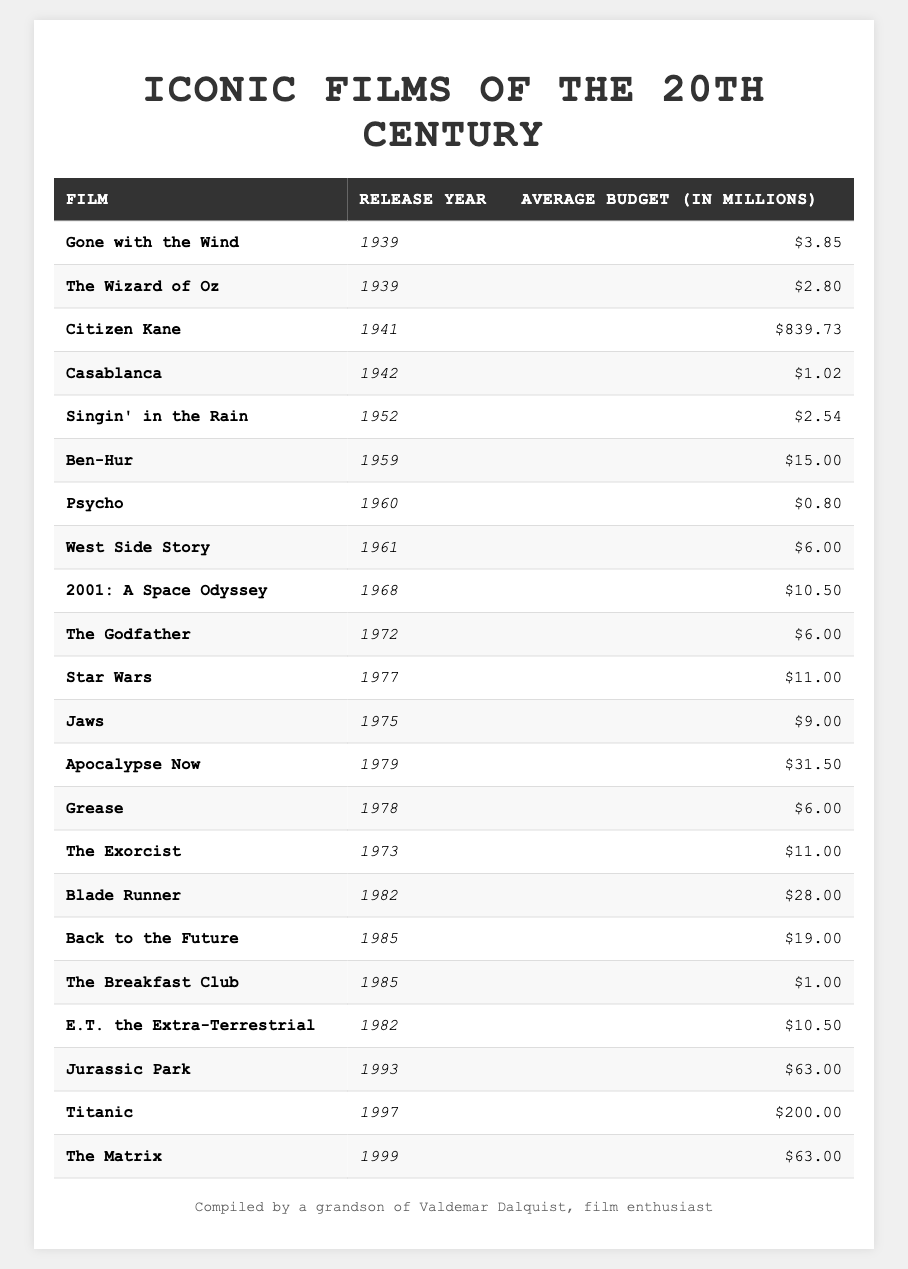What is the average budget of "Titanic"? The average budget listed for "Titanic" in the table is $200 million.
Answer: $200 million Which film was released in 1959 and what was its average budget? The film released in 1959 is "Ben-Hur", and the average budget is $15 million.
Answer: "Ben-Hur", $15 million How many films in the table have an average budget greater than $50 million? There are three films with an average budget greater than $50 million: "Jurassic Park", "Titanic", and "The Matrix".
Answer: 3 What was the average budget for films released in the 1970s? The average budget for films from the 1970s can be calculated by summing their budgets: $6 + $11 + $9 + $11 + $31.5 + $6 = $74.5 million and dividing by 6, which equals approximately $12.42 million.
Answer: Approximately $12.42 million Which film had the highest average budget and what was that budget? The film with the highest average budget is "Citizen Kane" with an average budget of $839.73 million.
Answer: "Citizen Kane", $839.73 million Was "Psycho" more expensive to make than "The Breakfast Club"? Yes, "Psycho" had an average budget of $0.8 million, while "The Breakfast Club" had an average budget of $1 million.
Answer: Yes List the films from the 1980s and calculate their average budget. The films from the 1980s are "Blade Runner" ($28 million), "E.T. the Extra-Terrestrial" ($10.5 million), "Back to the Future" ($19 million), and "The Breakfast Club" ($1 million). The total budget is $28 + $10.5 + $19 + $1 = $58.5 million, divided by 4 gives $14.625 million.
Answer: $14.625 million Is there any film in the table that was released in 1942? Yes, "Casablanca" was released in 1942.
Answer: Yes What is the difference in average budget between "Star Wars" and "Jaws"? The average budget for "Star Wars" is $11 million and for "Jaws" it is $9 million. The difference is $11 - $9 = $2 million.
Answer: $2 million How many films have a budget less than $5 million? There are five films with budgets less than $5 million: "Psycho", "Casablanca", "Singin' in the Rain", "The Wizard of Oz", and "Gone with the Wind".
Answer: 5 